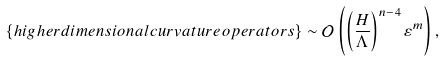Convert formula to latex. <formula><loc_0><loc_0><loc_500><loc_500>\left \{ h i g h e r d i m e n s i o n a l c u r v a t u r e o p e r a t o r s \right \} \sim { \mathcal { O } } \left ( \left ( \frac { H } { \Lambda } \right ) ^ { n - 4 } \varepsilon ^ { m } \right ) ,</formula> 